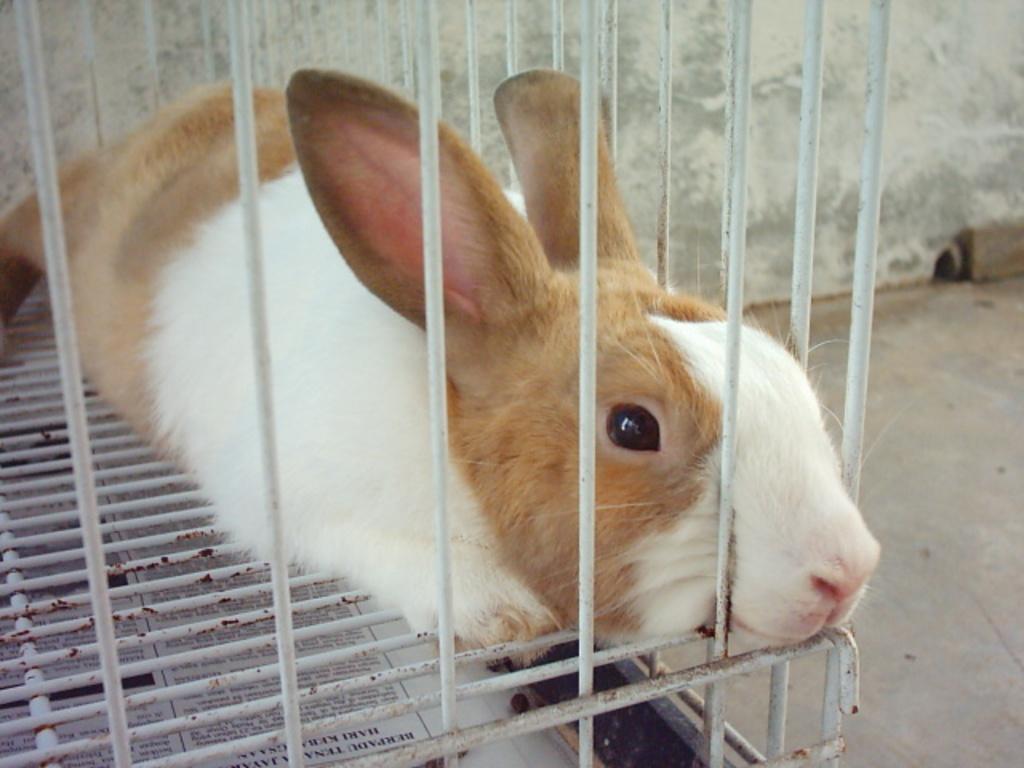Describe this image in one or two sentences. In this picture we can see a rabbit, who is sitting on the cage. On the bottom we can see newspaper. On the top right there is a wall. Here we can see hole. 